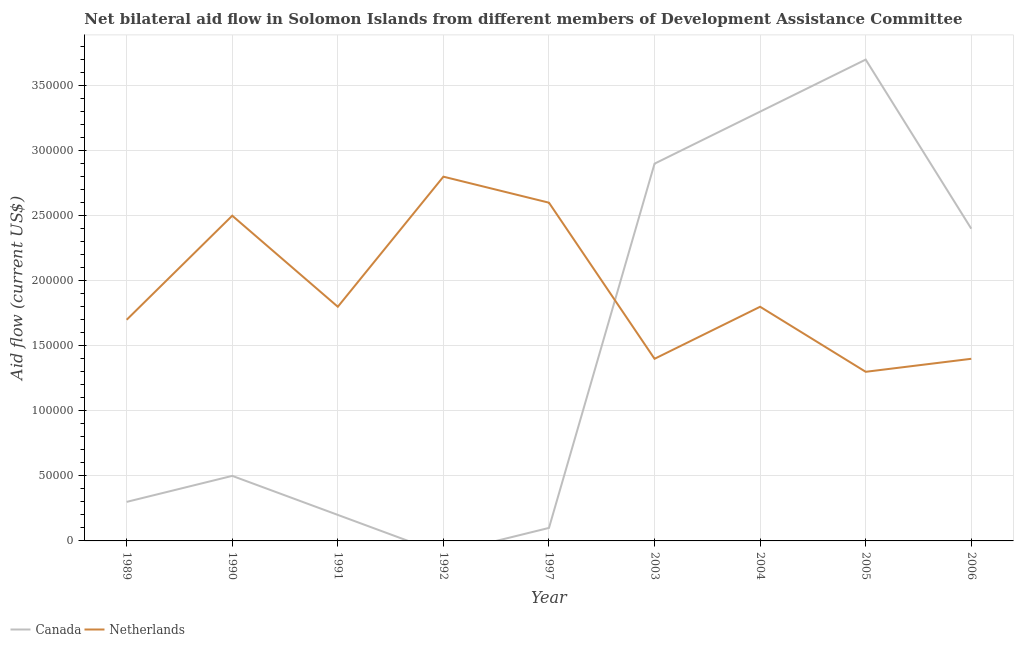Does the line corresponding to amount of aid given by netherlands intersect with the line corresponding to amount of aid given by canada?
Offer a very short reply. Yes. Is the number of lines equal to the number of legend labels?
Give a very brief answer. No. Across all years, what is the maximum amount of aid given by canada?
Offer a very short reply. 3.70e+05. Across all years, what is the minimum amount of aid given by canada?
Provide a succinct answer. 0. In which year was the amount of aid given by canada maximum?
Ensure brevity in your answer.  2005. What is the total amount of aid given by netherlands in the graph?
Make the answer very short. 1.73e+06. What is the difference between the amount of aid given by canada in 1997 and that in 2006?
Give a very brief answer. -2.30e+05. What is the difference between the amount of aid given by canada in 1992 and the amount of aid given by netherlands in 2005?
Offer a terse response. -1.30e+05. What is the average amount of aid given by canada per year?
Your answer should be very brief. 1.49e+05. In the year 1997, what is the difference between the amount of aid given by netherlands and amount of aid given by canada?
Give a very brief answer. 2.50e+05. What is the ratio of the amount of aid given by netherlands in 2003 to that in 2004?
Ensure brevity in your answer.  0.78. Is the amount of aid given by netherlands in 1990 less than that in 1997?
Offer a terse response. Yes. Is the difference between the amount of aid given by netherlands in 1989 and 2003 greater than the difference between the amount of aid given by canada in 1989 and 2003?
Offer a terse response. Yes. What is the difference between the highest and the second highest amount of aid given by canada?
Your response must be concise. 4.00e+04. What is the difference between the highest and the lowest amount of aid given by netherlands?
Make the answer very short. 1.50e+05. Is the sum of the amount of aid given by canada in 2003 and 2004 greater than the maximum amount of aid given by netherlands across all years?
Make the answer very short. Yes. Is the amount of aid given by netherlands strictly greater than the amount of aid given by canada over the years?
Make the answer very short. No. Is the amount of aid given by netherlands strictly less than the amount of aid given by canada over the years?
Your answer should be compact. No. What is the difference between two consecutive major ticks on the Y-axis?
Your response must be concise. 5.00e+04. Are the values on the major ticks of Y-axis written in scientific E-notation?
Offer a terse response. No. Does the graph contain any zero values?
Offer a terse response. Yes. Does the graph contain grids?
Ensure brevity in your answer.  Yes. How are the legend labels stacked?
Your response must be concise. Horizontal. What is the title of the graph?
Provide a short and direct response. Net bilateral aid flow in Solomon Islands from different members of Development Assistance Committee. What is the label or title of the Y-axis?
Ensure brevity in your answer.  Aid flow (current US$). What is the Aid flow (current US$) of Canada in 1989?
Give a very brief answer. 3.00e+04. What is the Aid flow (current US$) of Netherlands in 1990?
Offer a terse response. 2.50e+05. What is the Aid flow (current US$) in Canada in 1991?
Provide a succinct answer. 2.00e+04. What is the Aid flow (current US$) of Canada in 1992?
Ensure brevity in your answer.  0. What is the Aid flow (current US$) of Canada in 2003?
Make the answer very short. 2.90e+05. What is the Aid flow (current US$) of Netherlands in 2003?
Provide a short and direct response. 1.40e+05. What is the Aid flow (current US$) of Netherlands in 2005?
Provide a succinct answer. 1.30e+05. What is the Aid flow (current US$) in Netherlands in 2006?
Offer a very short reply. 1.40e+05. Across all years, what is the maximum Aid flow (current US$) in Canada?
Ensure brevity in your answer.  3.70e+05. Across all years, what is the minimum Aid flow (current US$) in Canada?
Your answer should be compact. 0. Across all years, what is the minimum Aid flow (current US$) of Netherlands?
Offer a very short reply. 1.30e+05. What is the total Aid flow (current US$) of Canada in the graph?
Ensure brevity in your answer.  1.34e+06. What is the total Aid flow (current US$) of Netherlands in the graph?
Give a very brief answer. 1.73e+06. What is the difference between the Aid flow (current US$) of Canada in 1989 and that in 1990?
Make the answer very short. -2.00e+04. What is the difference between the Aid flow (current US$) in Netherlands in 1989 and that in 1990?
Make the answer very short. -8.00e+04. What is the difference between the Aid flow (current US$) in Netherlands in 1989 and that in 1991?
Ensure brevity in your answer.  -10000. What is the difference between the Aid flow (current US$) in Netherlands in 1989 and that in 1997?
Ensure brevity in your answer.  -9.00e+04. What is the difference between the Aid flow (current US$) in Netherlands in 1989 and that in 2005?
Give a very brief answer. 4.00e+04. What is the difference between the Aid flow (current US$) of Canada in 1989 and that in 2006?
Your answer should be compact. -2.10e+05. What is the difference between the Aid flow (current US$) in Netherlands in 1990 and that in 1992?
Your response must be concise. -3.00e+04. What is the difference between the Aid flow (current US$) of Canada in 1990 and that in 1997?
Make the answer very short. 4.00e+04. What is the difference between the Aid flow (current US$) in Netherlands in 1990 and that in 1997?
Your response must be concise. -10000. What is the difference between the Aid flow (current US$) in Canada in 1990 and that in 2003?
Offer a very short reply. -2.40e+05. What is the difference between the Aid flow (current US$) in Netherlands in 1990 and that in 2003?
Keep it short and to the point. 1.10e+05. What is the difference between the Aid flow (current US$) in Canada in 1990 and that in 2004?
Make the answer very short. -2.80e+05. What is the difference between the Aid flow (current US$) of Canada in 1990 and that in 2005?
Provide a short and direct response. -3.20e+05. What is the difference between the Aid flow (current US$) in Netherlands in 1990 and that in 2005?
Provide a short and direct response. 1.20e+05. What is the difference between the Aid flow (current US$) of Netherlands in 1991 and that in 1997?
Provide a succinct answer. -8.00e+04. What is the difference between the Aid flow (current US$) of Netherlands in 1991 and that in 2003?
Keep it short and to the point. 4.00e+04. What is the difference between the Aid flow (current US$) in Canada in 1991 and that in 2004?
Offer a terse response. -3.10e+05. What is the difference between the Aid flow (current US$) in Canada in 1991 and that in 2005?
Provide a succinct answer. -3.50e+05. What is the difference between the Aid flow (current US$) of Canada in 1991 and that in 2006?
Make the answer very short. -2.20e+05. What is the difference between the Aid flow (current US$) of Netherlands in 1992 and that in 1997?
Provide a short and direct response. 2.00e+04. What is the difference between the Aid flow (current US$) of Netherlands in 1992 and that in 2006?
Provide a succinct answer. 1.40e+05. What is the difference between the Aid flow (current US$) of Canada in 1997 and that in 2003?
Keep it short and to the point. -2.80e+05. What is the difference between the Aid flow (current US$) in Canada in 1997 and that in 2004?
Ensure brevity in your answer.  -3.20e+05. What is the difference between the Aid flow (current US$) of Netherlands in 1997 and that in 2004?
Make the answer very short. 8.00e+04. What is the difference between the Aid flow (current US$) of Canada in 1997 and that in 2005?
Provide a short and direct response. -3.60e+05. What is the difference between the Aid flow (current US$) in Netherlands in 1997 and that in 2005?
Offer a terse response. 1.30e+05. What is the difference between the Aid flow (current US$) of Canada in 2003 and that in 2004?
Your answer should be very brief. -4.00e+04. What is the difference between the Aid flow (current US$) of Netherlands in 2003 and that in 2004?
Your response must be concise. -4.00e+04. What is the difference between the Aid flow (current US$) of Canada in 2003 and that in 2005?
Offer a very short reply. -8.00e+04. What is the difference between the Aid flow (current US$) in Canada in 2003 and that in 2006?
Provide a succinct answer. 5.00e+04. What is the difference between the Aid flow (current US$) of Netherlands in 2003 and that in 2006?
Your response must be concise. 0. What is the difference between the Aid flow (current US$) of Canada in 2005 and that in 2006?
Your answer should be very brief. 1.30e+05. What is the difference between the Aid flow (current US$) in Canada in 1989 and the Aid flow (current US$) in Netherlands in 1992?
Provide a succinct answer. -2.50e+05. What is the difference between the Aid flow (current US$) of Canada in 1989 and the Aid flow (current US$) of Netherlands in 1997?
Make the answer very short. -2.30e+05. What is the difference between the Aid flow (current US$) in Canada in 1989 and the Aid flow (current US$) in Netherlands in 2003?
Give a very brief answer. -1.10e+05. What is the difference between the Aid flow (current US$) in Canada in 1989 and the Aid flow (current US$) in Netherlands in 2004?
Give a very brief answer. -1.50e+05. What is the difference between the Aid flow (current US$) in Canada in 1989 and the Aid flow (current US$) in Netherlands in 2005?
Ensure brevity in your answer.  -1.00e+05. What is the difference between the Aid flow (current US$) in Canada in 1989 and the Aid flow (current US$) in Netherlands in 2006?
Your answer should be compact. -1.10e+05. What is the difference between the Aid flow (current US$) of Canada in 1990 and the Aid flow (current US$) of Netherlands in 1992?
Provide a succinct answer. -2.30e+05. What is the difference between the Aid flow (current US$) of Canada in 1990 and the Aid flow (current US$) of Netherlands in 1997?
Provide a short and direct response. -2.10e+05. What is the difference between the Aid flow (current US$) in Canada in 1990 and the Aid flow (current US$) in Netherlands in 2003?
Your answer should be very brief. -9.00e+04. What is the difference between the Aid flow (current US$) of Canada in 1990 and the Aid flow (current US$) of Netherlands in 2005?
Provide a short and direct response. -8.00e+04. What is the difference between the Aid flow (current US$) in Canada in 1990 and the Aid flow (current US$) in Netherlands in 2006?
Make the answer very short. -9.00e+04. What is the difference between the Aid flow (current US$) of Canada in 1991 and the Aid flow (current US$) of Netherlands in 1997?
Your answer should be compact. -2.40e+05. What is the difference between the Aid flow (current US$) in Canada in 1991 and the Aid flow (current US$) in Netherlands in 2003?
Offer a very short reply. -1.20e+05. What is the difference between the Aid flow (current US$) in Canada in 1991 and the Aid flow (current US$) in Netherlands in 2004?
Offer a terse response. -1.60e+05. What is the difference between the Aid flow (current US$) in Canada in 1991 and the Aid flow (current US$) in Netherlands in 2005?
Provide a succinct answer. -1.10e+05. What is the difference between the Aid flow (current US$) in Canada in 1997 and the Aid flow (current US$) in Netherlands in 2003?
Your answer should be very brief. -1.30e+05. What is the difference between the Aid flow (current US$) in Canada in 2003 and the Aid flow (current US$) in Netherlands in 2004?
Provide a succinct answer. 1.10e+05. What is the difference between the Aid flow (current US$) of Canada in 2005 and the Aid flow (current US$) of Netherlands in 2006?
Provide a succinct answer. 2.30e+05. What is the average Aid flow (current US$) in Canada per year?
Your answer should be compact. 1.49e+05. What is the average Aid flow (current US$) of Netherlands per year?
Offer a terse response. 1.92e+05. In the year 1991, what is the difference between the Aid flow (current US$) in Canada and Aid flow (current US$) in Netherlands?
Your response must be concise. -1.60e+05. In the year 2003, what is the difference between the Aid flow (current US$) in Canada and Aid flow (current US$) in Netherlands?
Offer a very short reply. 1.50e+05. In the year 2004, what is the difference between the Aid flow (current US$) of Canada and Aid flow (current US$) of Netherlands?
Give a very brief answer. 1.50e+05. In the year 2005, what is the difference between the Aid flow (current US$) of Canada and Aid flow (current US$) of Netherlands?
Offer a very short reply. 2.40e+05. What is the ratio of the Aid flow (current US$) of Canada in 1989 to that in 1990?
Provide a short and direct response. 0.6. What is the ratio of the Aid flow (current US$) in Netherlands in 1989 to that in 1990?
Give a very brief answer. 0.68. What is the ratio of the Aid flow (current US$) in Canada in 1989 to that in 1991?
Offer a terse response. 1.5. What is the ratio of the Aid flow (current US$) of Netherlands in 1989 to that in 1992?
Your answer should be compact. 0.61. What is the ratio of the Aid flow (current US$) in Netherlands in 1989 to that in 1997?
Offer a very short reply. 0.65. What is the ratio of the Aid flow (current US$) in Canada in 1989 to that in 2003?
Offer a very short reply. 0.1. What is the ratio of the Aid flow (current US$) of Netherlands in 1989 to that in 2003?
Offer a terse response. 1.21. What is the ratio of the Aid flow (current US$) in Canada in 1989 to that in 2004?
Your response must be concise. 0.09. What is the ratio of the Aid flow (current US$) of Canada in 1989 to that in 2005?
Provide a short and direct response. 0.08. What is the ratio of the Aid flow (current US$) in Netherlands in 1989 to that in 2005?
Your answer should be very brief. 1.31. What is the ratio of the Aid flow (current US$) in Netherlands in 1989 to that in 2006?
Your answer should be compact. 1.21. What is the ratio of the Aid flow (current US$) of Canada in 1990 to that in 1991?
Give a very brief answer. 2.5. What is the ratio of the Aid flow (current US$) of Netherlands in 1990 to that in 1991?
Provide a short and direct response. 1.39. What is the ratio of the Aid flow (current US$) in Netherlands in 1990 to that in 1992?
Your answer should be compact. 0.89. What is the ratio of the Aid flow (current US$) in Canada in 1990 to that in 1997?
Your answer should be very brief. 5. What is the ratio of the Aid flow (current US$) in Netherlands in 1990 to that in 1997?
Provide a succinct answer. 0.96. What is the ratio of the Aid flow (current US$) of Canada in 1990 to that in 2003?
Offer a terse response. 0.17. What is the ratio of the Aid flow (current US$) of Netherlands in 1990 to that in 2003?
Ensure brevity in your answer.  1.79. What is the ratio of the Aid flow (current US$) of Canada in 1990 to that in 2004?
Provide a short and direct response. 0.15. What is the ratio of the Aid flow (current US$) of Netherlands in 1990 to that in 2004?
Give a very brief answer. 1.39. What is the ratio of the Aid flow (current US$) in Canada in 1990 to that in 2005?
Ensure brevity in your answer.  0.14. What is the ratio of the Aid flow (current US$) in Netherlands in 1990 to that in 2005?
Your answer should be very brief. 1.92. What is the ratio of the Aid flow (current US$) of Canada in 1990 to that in 2006?
Keep it short and to the point. 0.21. What is the ratio of the Aid flow (current US$) of Netherlands in 1990 to that in 2006?
Your answer should be very brief. 1.79. What is the ratio of the Aid flow (current US$) of Netherlands in 1991 to that in 1992?
Provide a succinct answer. 0.64. What is the ratio of the Aid flow (current US$) in Netherlands in 1991 to that in 1997?
Provide a short and direct response. 0.69. What is the ratio of the Aid flow (current US$) in Canada in 1991 to that in 2003?
Offer a terse response. 0.07. What is the ratio of the Aid flow (current US$) in Netherlands in 1991 to that in 2003?
Keep it short and to the point. 1.29. What is the ratio of the Aid flow (current US$) in Canada in 1991 to that in 2004?
Provide a short and direct response. 0.06. What is the ratio of the Aid flow (current US$) of Canada in 1991 to that in 2005?
Your answer should be very brief. 0.05. What is the ratio of the Aid flow (current US$) of Netherlands in 1991 to that in 2005?
Provide a short and direct response. 1.38. What is the ratio of the Aid flow (current US$) of Canada in 1991 to that in 2006?
Your answer should be compact. 0.08. What is the ratio of the Aid flow (current US$) in Netherlands in 1991 to that in 2006?
Give a very brief answer. 1.29. What is the ratio of the Aid flow (current US$) in Netherlands in 1992 to that in 1997?
Give a very brief answer. 1.08. What is the ratio of the Aid flow (current US$) of Netherlands in 1992 to that in 2003?
Give a very brief answer. 2. What is the ratio of the Aid flow (current US$) of Netherlands in 1992 to that in 2004?
Your answer should be very brief. 1.56. What is the ratio of the Aid flow (current US$) in Netherlands in 1992 to that in 2005?
Your answer should be compact. 2.15. What is the ratio of the Aid flow (current US$) in Canada in 1997 to that in 2003?
Provide a short and direct response. 0.03. What is the ratio of the Aid flow (current US$) of Netherlands in 1997 to that in 2003?
Give a very brief answer. 1.86. What is the ratio of the Aid flow (current US$) of Canada in 1997 to that in 2004?
Make the answer very short. 0.03. What is the ratio of the Aid flow (current US$) in Netherlands in 1997 to that in 2004?
Your answer should be very brief. 1.44. What is the ratio of the Aid flow (current US$) in Canada in 1997 to that in 2005?
Ensure brevity in your answer.  0.03. What is the ratio of the Aid flow (current US$) of Netherlands in 1997 to that in 2005?
Offer a terse response. 2. What is the ratio of the Aid flow (current US$) in Canada in 1997 to that in 2006?
Your response must be concise. 0.04. What is the ratio of the Aid flow (current US$) in Netherlands in 1997 to that in 2006?
Your response must be concise. 1.86. What is the ratio of the Aid flow (current US$) of Canada in 2003 to that in 2004?
Offer a terse response. 0.88. What is the ratio of the Aid flow (current US$) of Netherlands in 2003 to that in 2004?
Provide a short and direct response. 0.78. What is the ratio of the Aid flow (current US$) in Canada in 2003 to that in 2005?
Your answer should be compact. 0.78. What is the ratio of the Aid flow (current US$) in Canada in 2003 to that in 2006?
Offer a terse response. 1.21. What is the ratio of the Aid flow (current US$) of Netherlands in 2003 to that in 2006?
Keep it short and to the point. 1. What is the ratio of the Aid flow (current US$) of Canada in 2004 to that in 2005?
Make the answer very short. 0.89. What is the ratio of the Aid flow (current US$) in Netherlands in 2004 to that in 2005?
Provide a succinct answer. 1.38. What is the ratio of the Aid flow (current US$) in Canada in 2004 to that in 2006?
Your answer should be very brief. 1.38. What is the ratio of the Aid flow (current US$) in Canada in 2005 to that in 2006?
Ensure brevity in your answer.  1.54. 